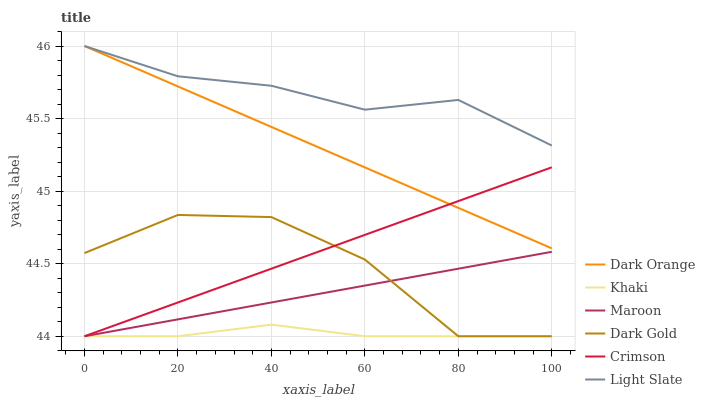Does Khaki have the minimum area under the curve?
Answer yes or no. Yes. Does Light Slate have the maximum area under the curve?
Answer yes or no. Yes. Does Dark Gold have the minimum area under the curve?
Answer yes or no. No. Does Dark Gold have the maximum area under the curve?
Answer yes or no. No. Is Maroon the smoothest?
Answer yes or no. Yes. Is Dark Gold the roughest?
Answer yes or no. Yes. Is Khaki the smoothest?
Answer yes or no. No. Is Khaki the roughest?
Answer yes or no. No. Does Khaki have the lowest value?
Answer yes or no. Yes. Does Light Slate have the lowest value?
Answer yes or no. No. Does Light Slate have the highest value?
Answer yes or no. Yes. Does Dark Gold have the highest value?
Answer yes or no. No. Is Maroon less than Dark Orange?
Answer yes or no. Yes. Is Light Slate greater than Maroon?
Answer yes or no. Yes. Does Dark Orange intersect Light Slate?
Answer yes or no. Yes. Is Dark Orange less than Light Slate?
Answer yes or no. No. Is Dark Orange greater than Light Slate?
Answer yes or no. No. Does Maroon intersect Dark Orange?
Answer yes or no. No. 